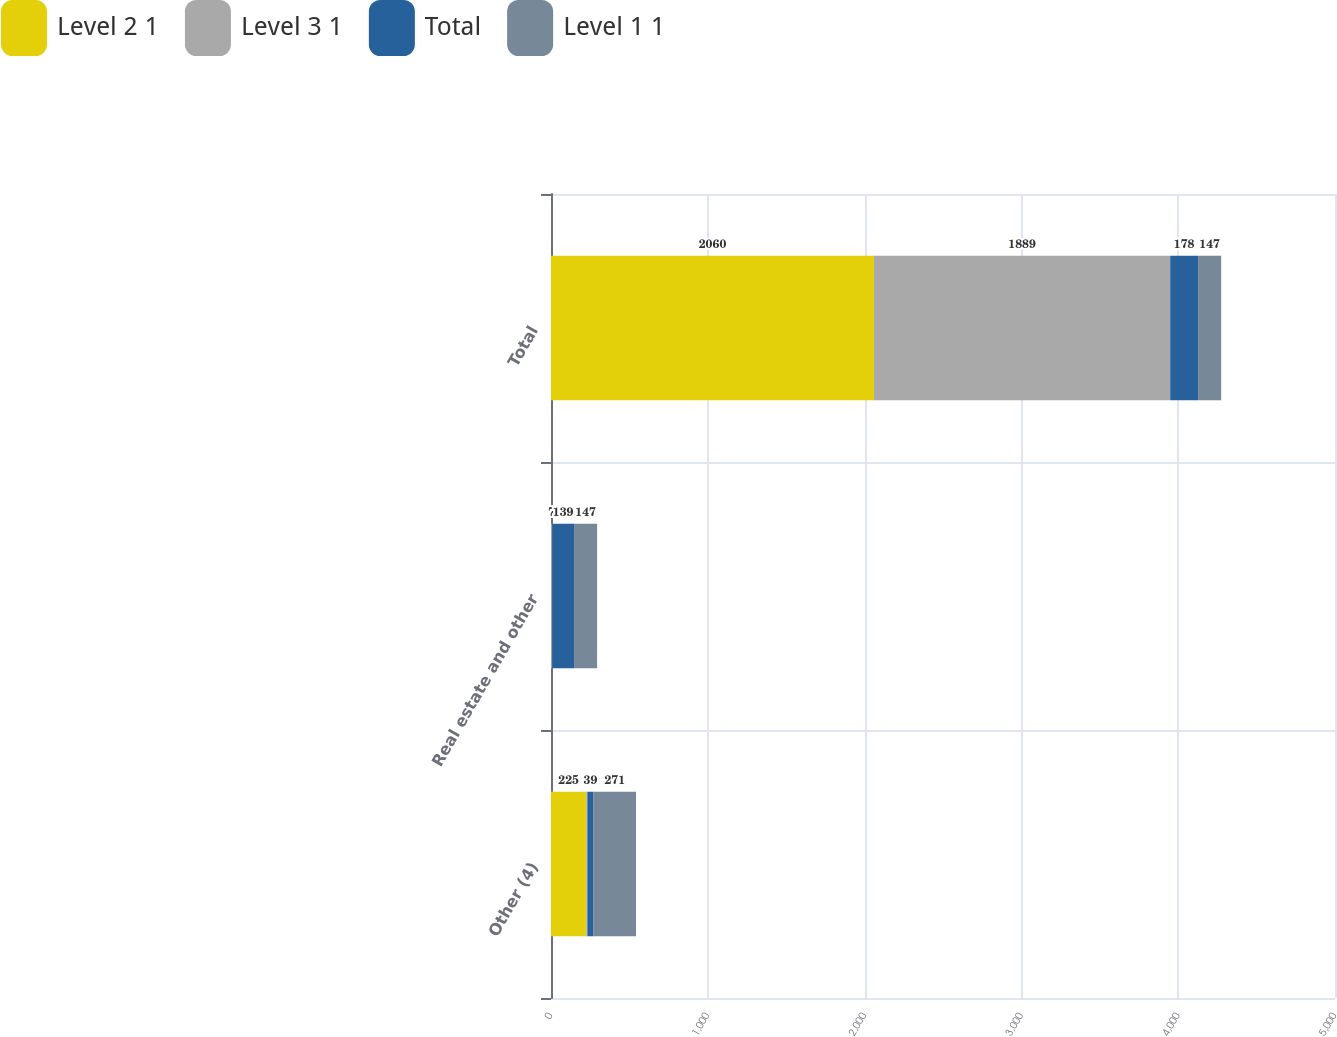Convert chart. <chart><loc_0><loc_0><loc_500><loc_500><stacked_bar_chart><ecel><fcel>Other (4)<fcel>Real estate and other<fcel>Total<nl><fcel>Level 2 1<fcel>225<fcel>1<fcel>2060<nl><fcel>Level 3 1<fcel>7<fcel>7<fcel>1889<nl><fcel>Total<fcel>39<fcel>139<fcel>178<nl><fcel>Level 1 1<fcel>271<fcel>147<fcel>147<nl></chart> 